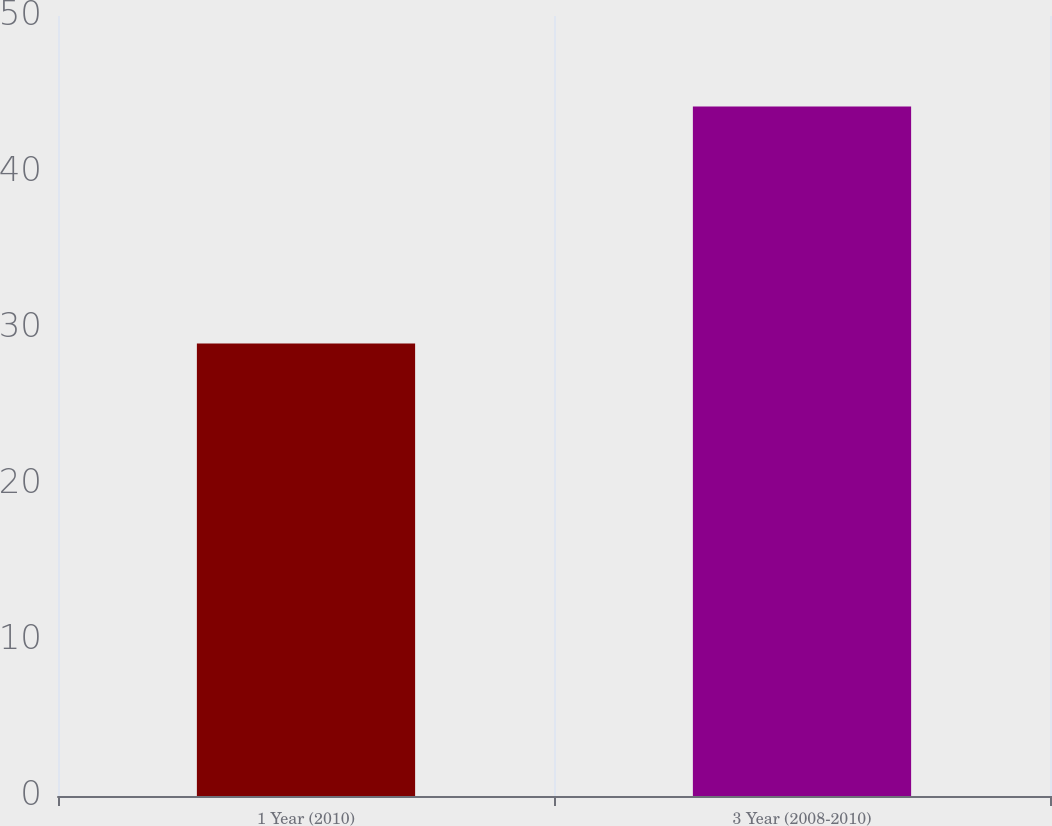Convert chart to OTSL. <chart><loc_0><loc_0><loc_500><loc_500><bar_chart><fcel>1 Year (2010)<fcel>3 Year (2008-2010)<nl><fcel>29<fcel>44.2<nl></chart> 